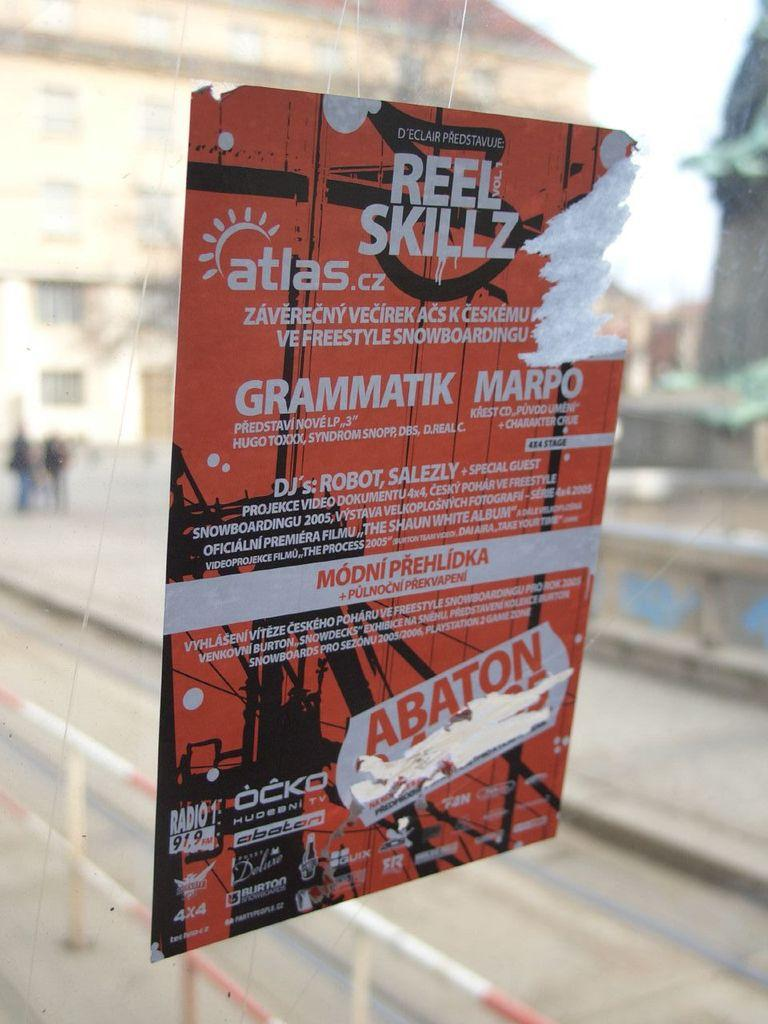<image>
Describe the image concisely. A poster for an event that is called Reel Skillz. 